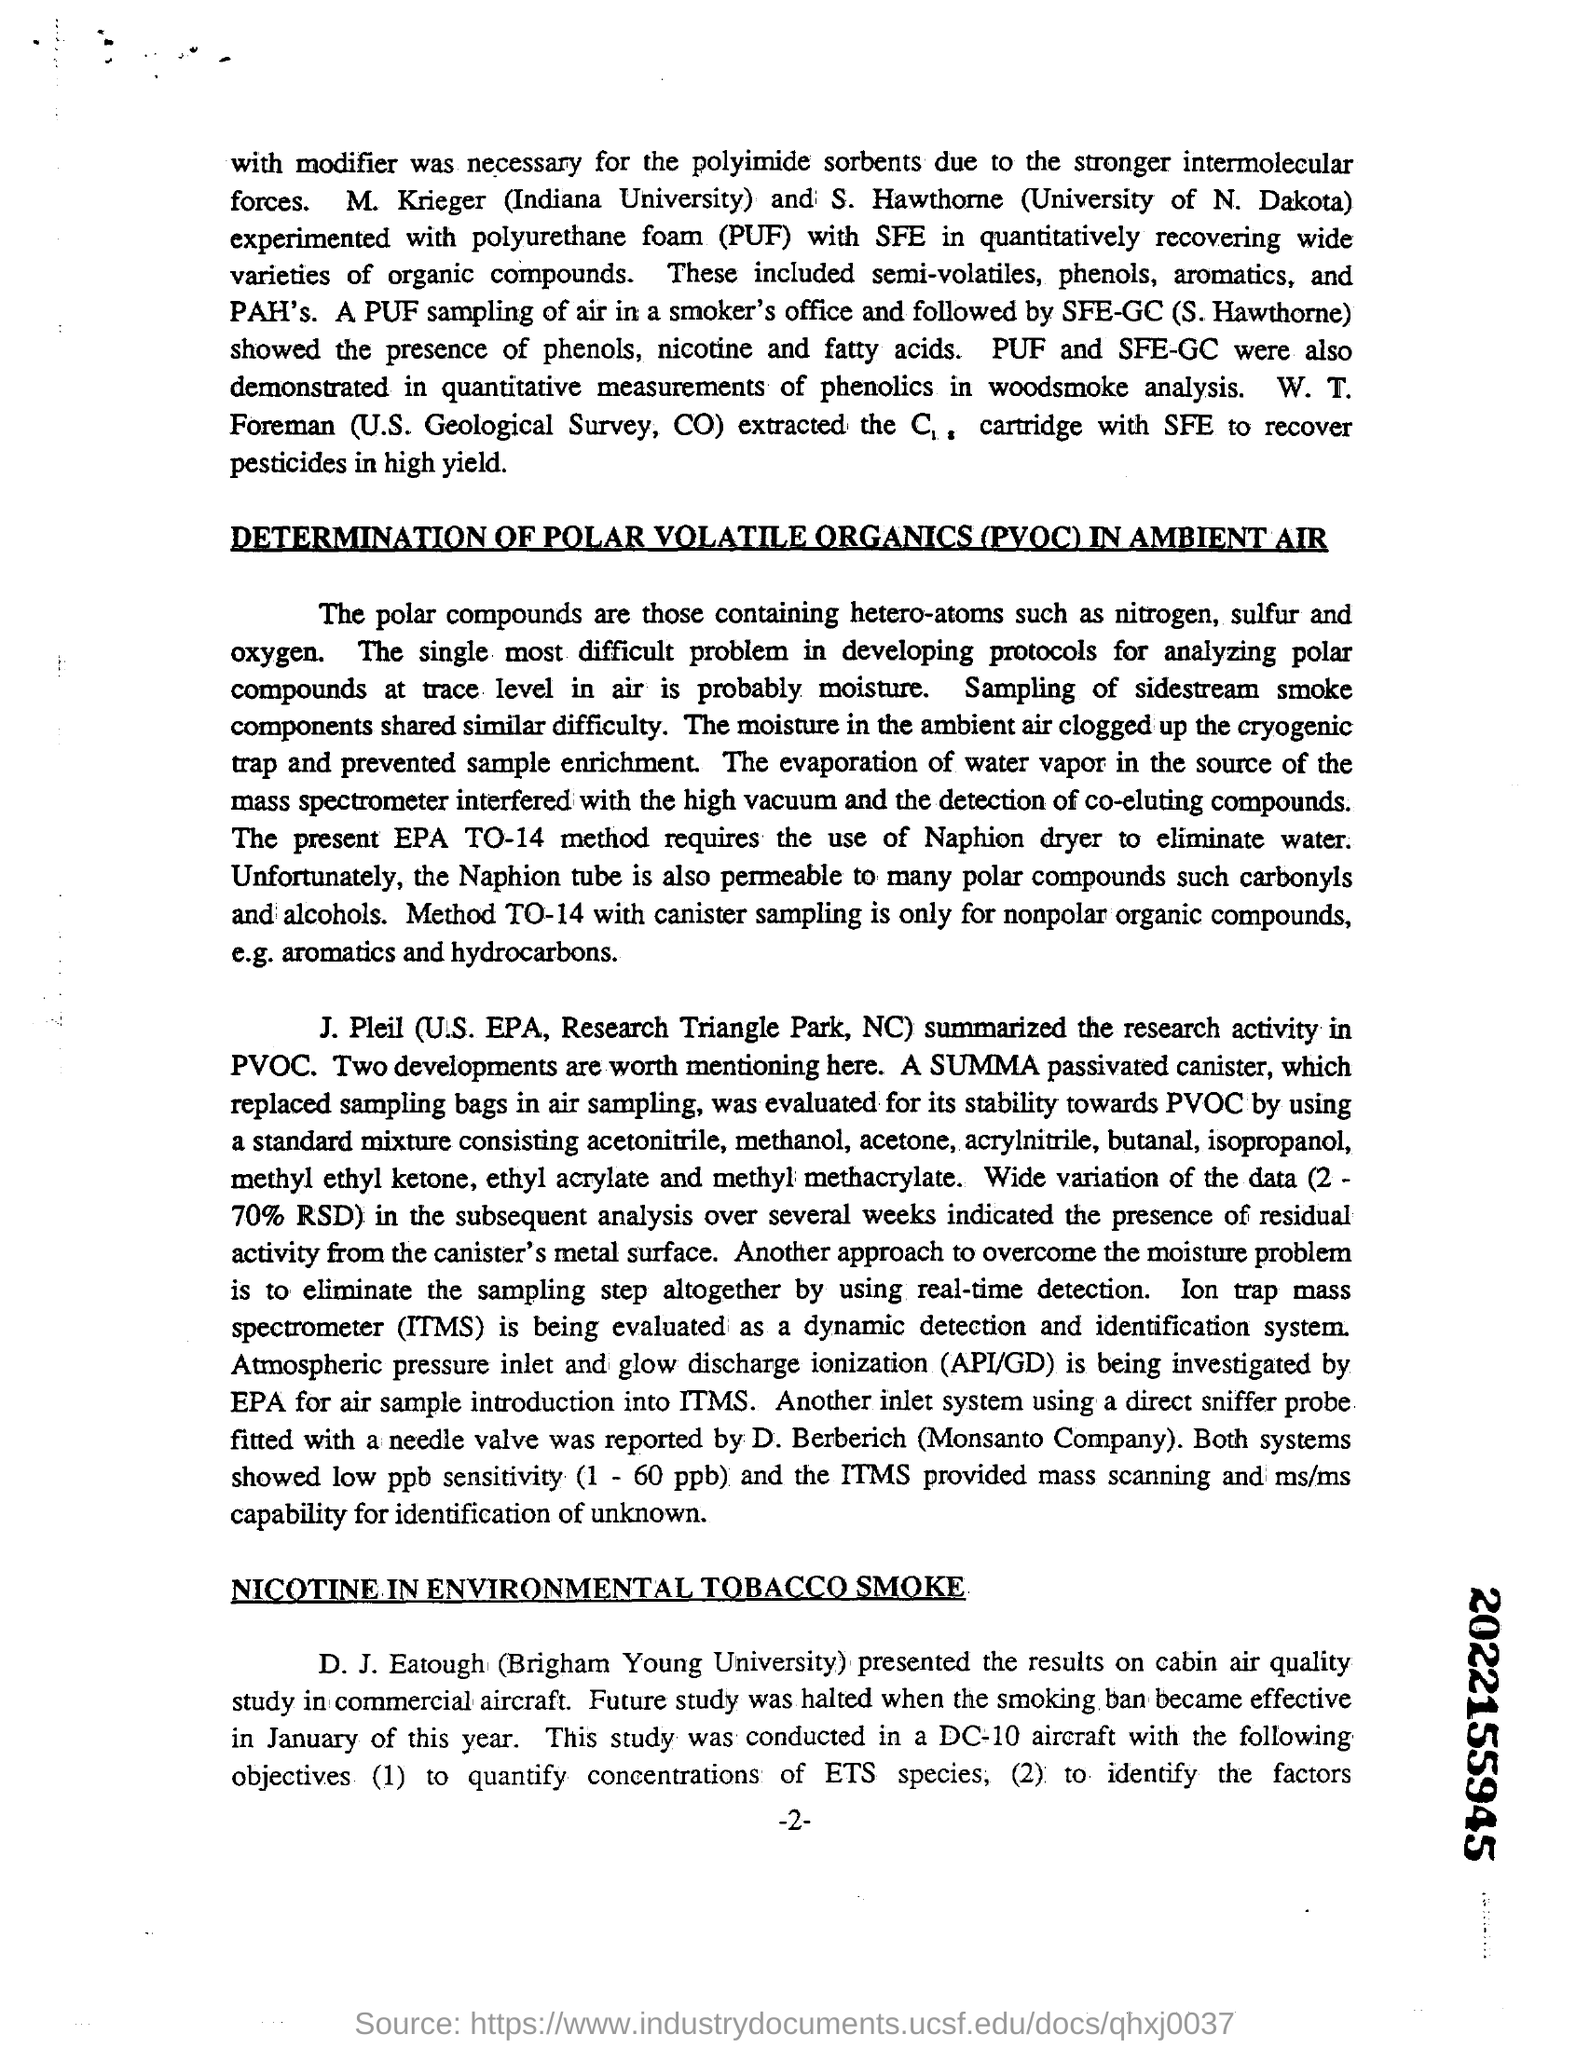What is the full form of PUF?
Your response must be concise. POLYURETHANE FOAM. Which hetero-atoms  does polar compounds contain?
Your response must be concise. Nitrogen, sulfur and oxygen. What is the full form of POVC?
Keep it short and to the point. POLAR VOLATILE ORGANICS. Who presented the results on cabin air quality study in commercial aircraft?
Offer a very short reply. D. J. EATOUGH. 